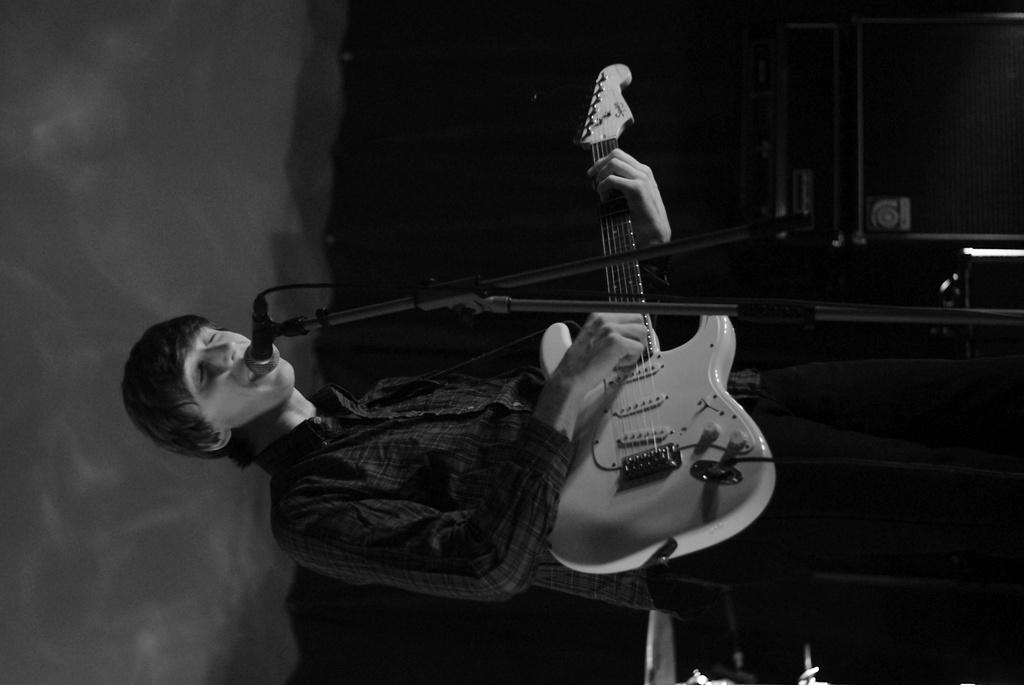What is the man in the image doing? The man is standing in front of a mic and holding a guitar. What can be inferred about the man's activity from the image? The man is likely performing or preparing to perform, given the presence of a mic and a guitar. What is visible in the background of the image? There are equipment visible in the background of the image. How would you describe the lighting in the image? The background of the image is dark. What type of religious ceremony is the man participating in, as seen in the image? There is no indication of a religious ceremony in the image; the man is holding a guitar and standing in front of a mic, suggesting a musical performance. What is the size of the bubble that the man is blowing in the image? There is no bubble present in the image. 